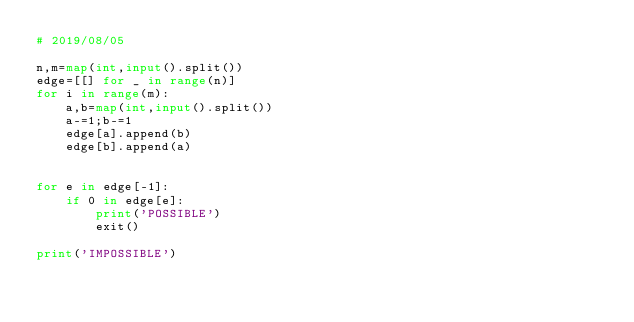Convert code to text. <code><loc_0><loc_0><loc_500><loc_500><_Python_># 2019/08/05

n,m=map(int,input().split())
edge=[[] for _ in range(n)]
for i in range(m):
    a,b=map(int,input().split())
    a-=1;b-=1
    edge[a].append(b)
    edge[b].append(a)


for e in edge[-1]:
    if 0 in edge[e]:
        print('POSSIBLE')
        exit()

print('IMPOSSIBLE')</code> 